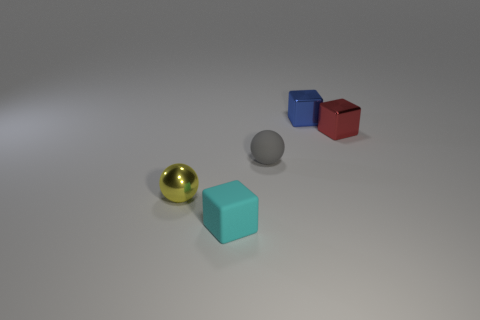Subtract all tiny shiny cubes. How many cubes are left? 1 Add 1 small rubber blocks. How many objects exist? 6 Subtract all blue blocks. How many blocks are left? 2 Subtract all cubes. How many objects are left? 2 Subtract all purple cubes. Subtract all gray balls. How many cubes are left? 3 Subtract all blue shiny blocks. Subtract all small blue metal blocks. How many objects are left? 3 Add 1 yellow spheres. How many yellow spheres are left? 2 Add 3 small red shiny things. How many small red shiny things exist? 4 Subtract 1 gray balls. How many objects are left? 4 